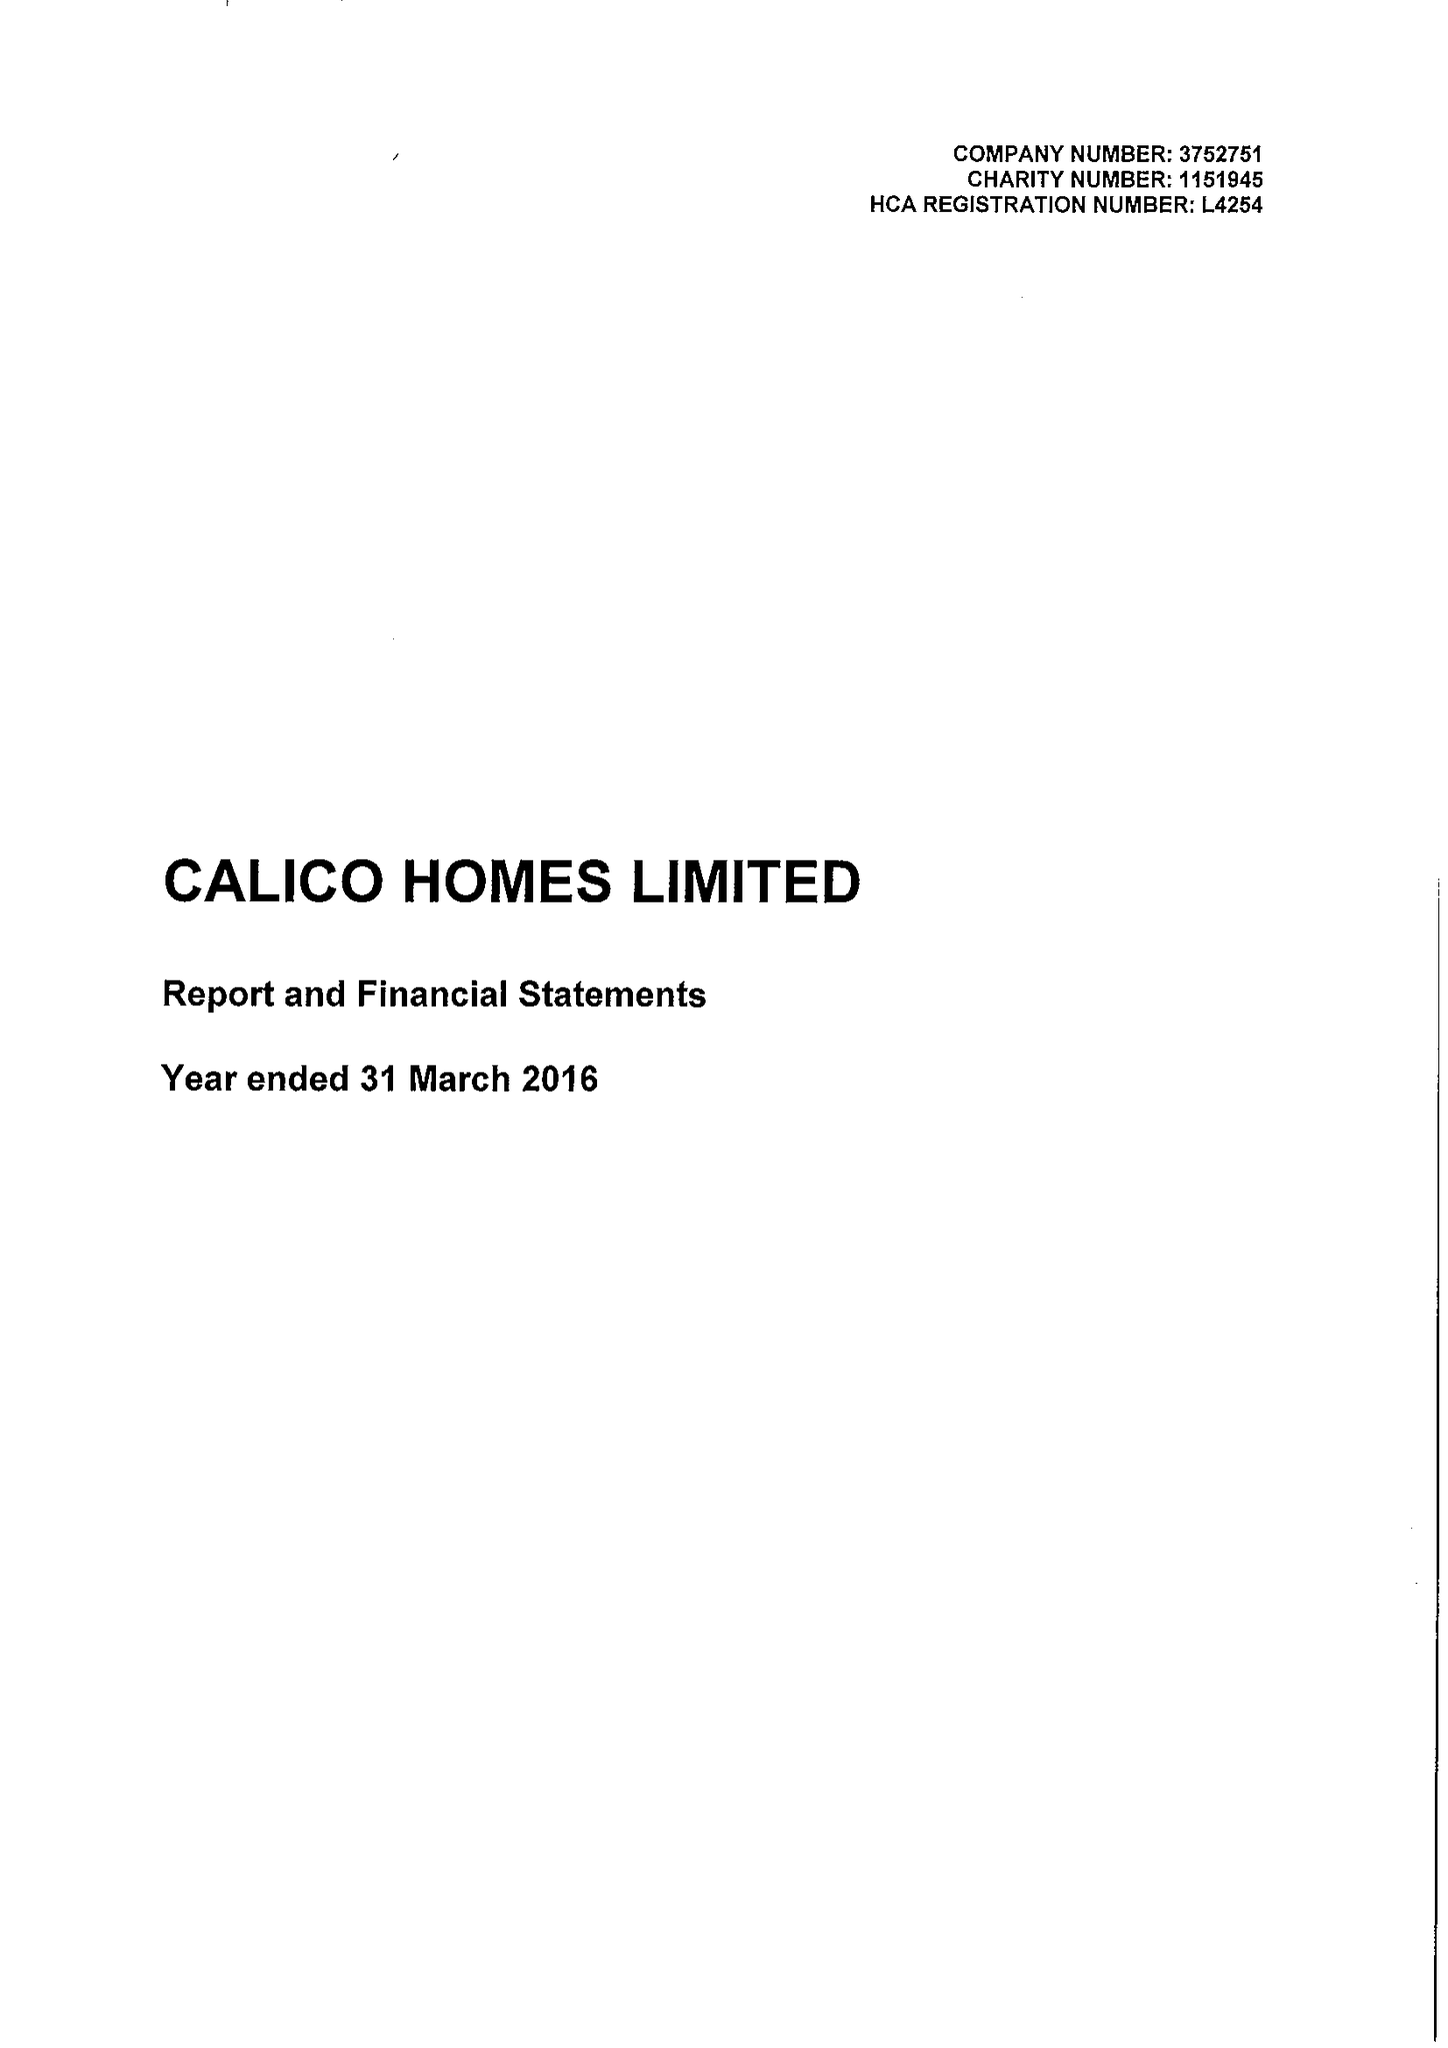What is the value for the charity_number?
Answer the question using a single word or phrase. 1151945 